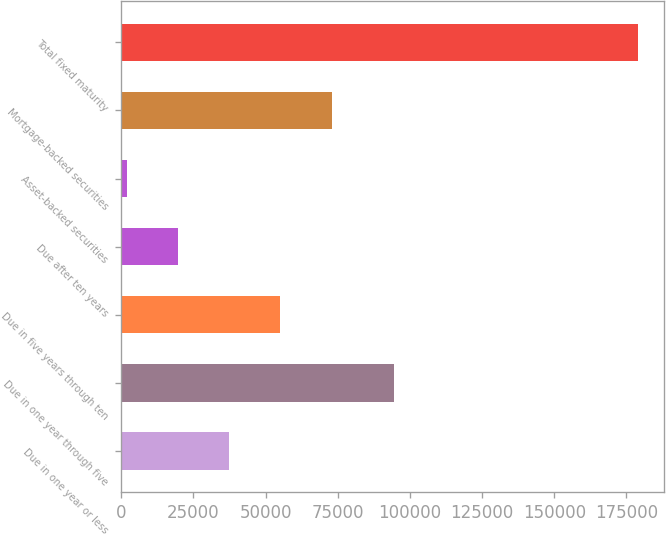Convert chart. <chart><loc_0><loc_0><loc_500><loc_500><bar_chart><fcel>Due in one year or less<fcel>Due in one year through five<fcel>Due in five years through ten<fcel>Due after ten years<fcel>Asset-backed securities<fcel>Mortgage-backed securities<fcel>Total fixed maturity<nl><fcel>37421.8<fcel>94623<fcel>55141.7<fcel>19701.9<fcel>1982<fcel>72861.6<fcel>179181<nl></chart> 